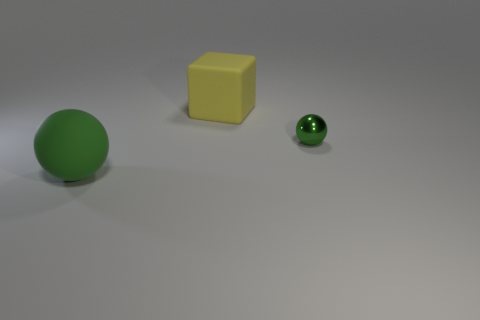What is the shape of the green rubber object?
Make the answer very short. Sphere. There is a big thing that is in front of the small green metallic ball; are there any matte blocks that are in front of it?
Your response must be concise. No. There is a yellow object that is the same size as the green rubber thing; what material is it?
Offer a terse response. Rubber. Are there any green balls of the same size as the yellow matte block?
Your answer should be very brief. Yes. There is a green thing right of the large green ball; what is its material?
Offer a very short reply. Metal. Do the green ball right of the yellow object and the big yellow object have the same material?
Your response must be concise. No. The green matte thing that is the same size as the yellow rubber cube is what shape?
Provide a short and direct response. Sphere. How many large cubes have the same color as the tiny metal object?
Your response must be concise. 0. Are there fewer objects in front of the yellow matte thing than matte blocks that are right of the tiny sphere?
Your answer should be very brief. No. There is a yellow rubber thing; are there any small green metal objects behind it?
Offer a very short reply. No. 